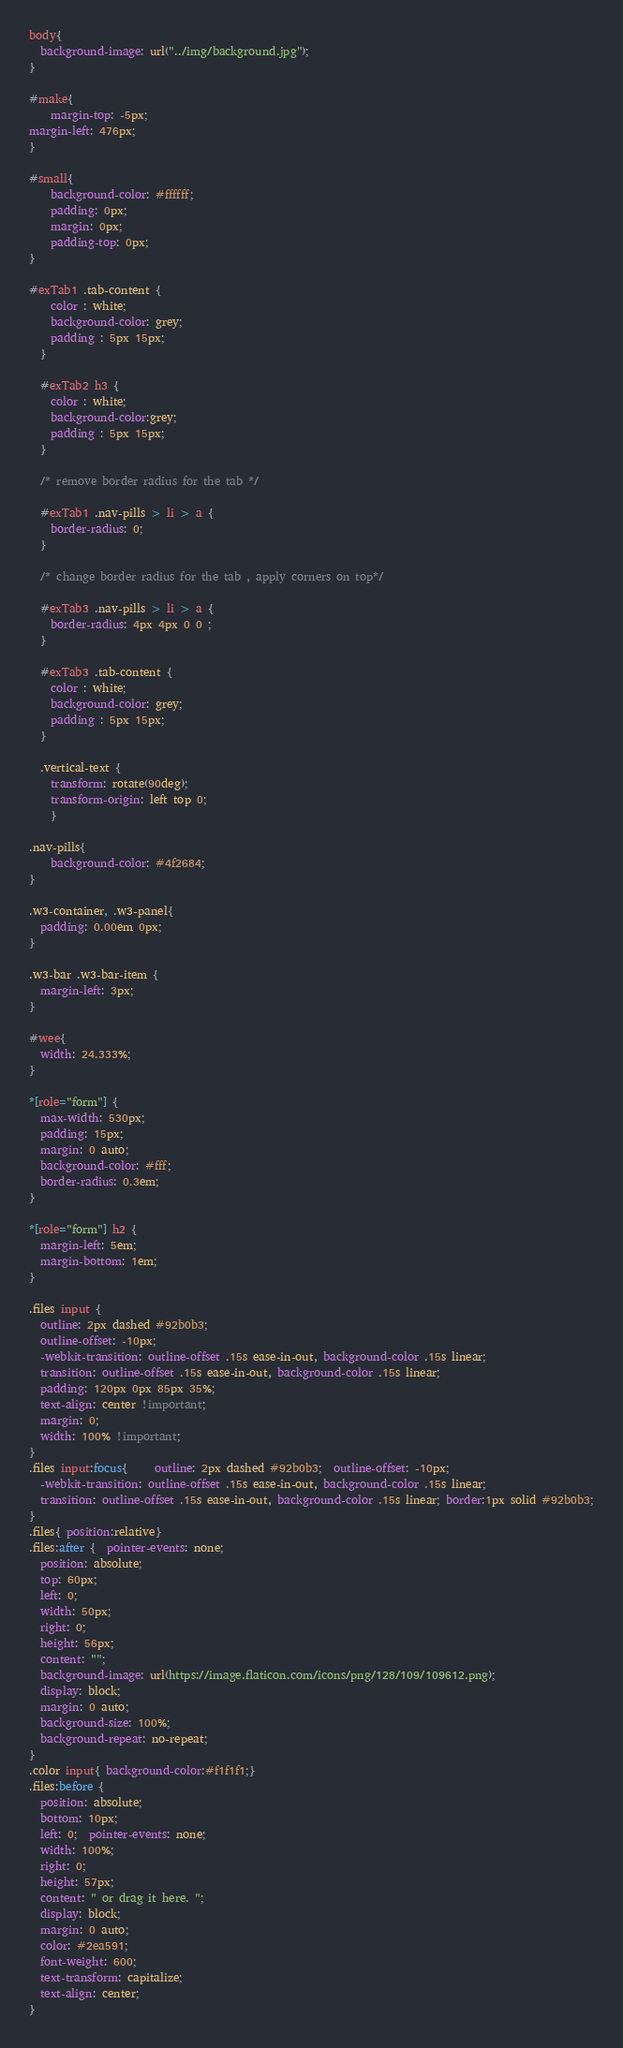<code> <loc_0><loc_0><loc_500><loc_500><_CSS_>body{
  background-image: url("../img/background.jpg");
}

#make{
    margin-top: -5px;
margin-left: 476px;
}

#small{
    background-color: #ffffff;
    padding: 0px;
    margin: 0px;
    padding-top: 0px;
}

#exTab1 .tab-content {
    color : white;
    background-color: grey;
    padding : 5px 15px;
  }
  
  #exTab2 h3 {
    color : white;
    background-color:grey;
    padding : 5px 15px;
  }
  
  /* remove border radius for the tab */
  
  #exTab1 .nav-pills > li > a {
    border-radius: 0;
  }
  
  /* change border radius for the tab , apply corners on top*/
  
  #exTab3 .nav-pills > li > a {
    border-radius: 4px 4px 0 0 ;
  }
  
  #exTab3 .tab-content {
    color : white;
    background-color: grey;
    padding : 5px 15px;
  }

  .vertical-text {
    transform: rotate(90deg);
    transform-origin: left top 0;
    }

.nav-pills{
    background-color: #4f2684;
}

.w3-container, .w3-panel{
  padding: 0.00em 0px;
}

.w3-bar .w3-bar-item {
  margin-left: 3px;
}

#wee{
  width: 24.333%;
}

*[role="form"] {
  max-width: 530px;
  padding: 15px;
  margin: 0 auto;
  background-color: #fff;
  border-radius: 0.3em;
}

*[role="form"] h2 {
  margin-left: 5em;
  margin-bottom: 1em;
}

.files input {
  outline: 2px dashed #92b0b3;
  outline-offset: -10px;
  -webkit-transition: outline-offset .15s ease-in-out, background-color .15s linear;
  transition: outline-offset .15s ease-in-out, background-color .15s linear;
  padding: 120px 0px 85px 35%;
  text-align: center !important;
  margin: 0;
  width: 100% !important;
}
.files input:focus{     outline: 2px dashed #92b0b3;  outline-offset: -10px;
  -webkit-transition: outline-offset .15s ease-in-out, background-color .15s linear;
  transition: outline-offset .15s ease-in-out, background-color .15s linear; border:1px solid #92b0b3;
}
.files{ position:relative}
.files:after {  pointer-events: none;
  position: absolute;
  top: 60px;
  left: 0;
  width: 50px;
  right: 0;
  height: 56px;
  content: "";
  background-image: url(https://image.flaticon.com/icons/png/128/109/109612.png);
  display: block;
  margin: 0 auto;
  background-size: 100%;
  background-repeat: no-repeat;
}
.color input{ background-color:#f1f1f1;}
.files:before {
  position: absolute;
  bottom: 10px;
  left: 0;  pointer-events: none;
  width: 100%;
  right: 0;
  height: 57px;
  content: " or drag it here. ";
  display: block;
  margin: 0 auto;
  color: #2ea591;
  font-weight: 600;
  text-transform: capitalize;
  text-align: center;
}</code> 